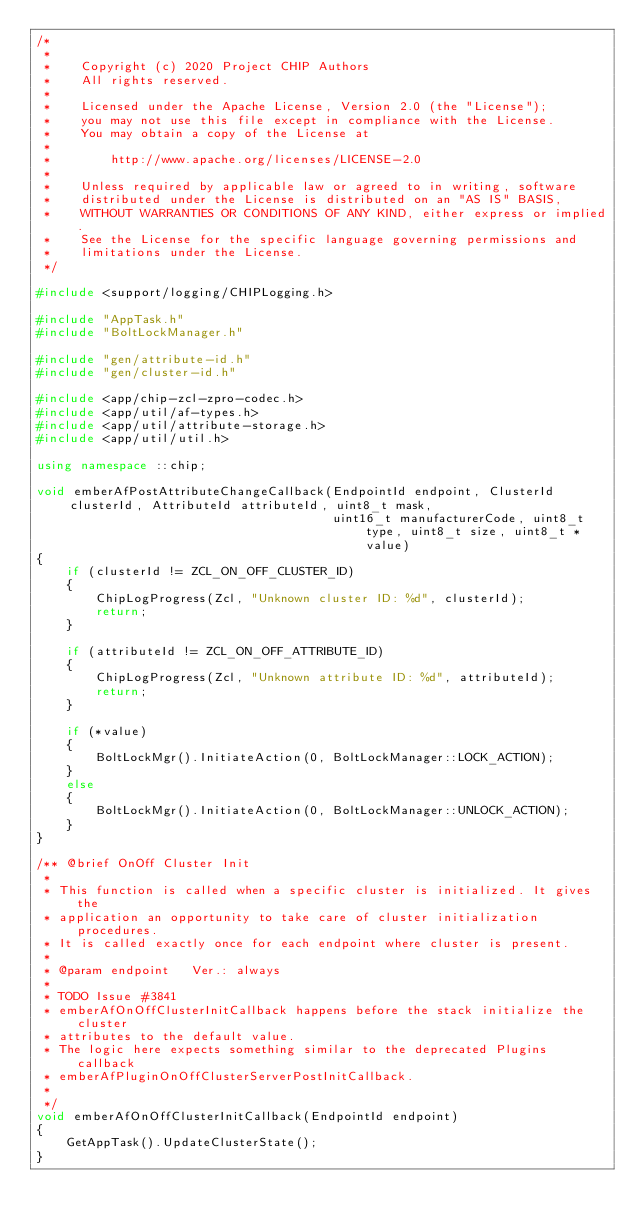<code> <loc_0><loc_0><loc_500><loc_500><_C++_>/*
 *
 *    Copyright (c) 2020 Project CHIP Authors
 *    All rights reserved.
 *
 *    Licensed under the Apache License, Version 2.0 (the "License");
 *    you may not use this file except in compliance with the License.
 *    You may obtain a copy of the License at
 *
 *        http://www.apache.org/licenses/LICENSE-2.0
 *
 *    Unless required by applicable law or agreed to in writing, software
 *    distributed under the License is distributed on an "AS IS" BASIS,
 *    WITHOUT WARRANTIES OR CONDITIONS OF ANY KIND, either express or implied.
 *    See the License for the specific language governing permissions and
 *    limitations under the License.
 */

#include <support/logging/CHIPLogging.h>

#include "AppTask.h"
#include "BoltLockManager.h"

#include "gen/attribute-id.h"
#include "gen/cluster-id.h"

#include <app/chip-zcl-zpro-codec.h>
#include <app/util/af-types.h>
#include <app/util/attribute-storage.h>
#include <app/util/util.h>

using namespace ::chip;

void emberAfPostAttributeChangeCallback(EndpointId endpoint, ClusterId clusterId, AttributeId attributeId, uint8_t mask,
                                        uint16_t manufacturerCode, uint8_t type, uint8_t size, uint8_t * value)
{
    if (clusterId != ZCL_ON_OFF_CLUSTER_ID)
    {
        ChipLogProgress(Zcl, "Unknown cluster ID: %d", clusterId);
        return;
    }

    if (attributeId != ZCL_ON_OFF_ATTRIBUTE_ID)
    {
        ChipLogProgress(Zcl, "Unknown attribute ID: %d", attributeId);
        return;
    }

    if (*value)
    {
        BoltLockMgr().InitiateAction(0, BoltLockManager::LOCK_ACTION);
    }
    else
    {
        BoltLockMgr().InitiateAction(0, BoltLockManager::UNLOCK_ACTION);
    }
}

/** @brief OnOff Cluster Init
 *
 * This function is called when a specific cluster is initialized. It gives the
 * application an opportunity to take care of cluster initialization procedures.
 * It is called exactly once for each endpoint where cluster is present.
 *
 * @param endpoint   Ver.: always
 *
 * TODO Issue #3841
 * emberAfOnOffClusterInitCallback happens before the stack initialize the cluster
 * attributes to the default value.
 * The logic here expects something similar to the deprecated Plugins callback
 * emberAfPluginOnOffClusterServerPostInitCallback.
 *
 */
void emberAfOnOffClusterInitCallback(EndpointId endpoint)
{
    GetAppTask().UpdateClusterState();
}
</code> 